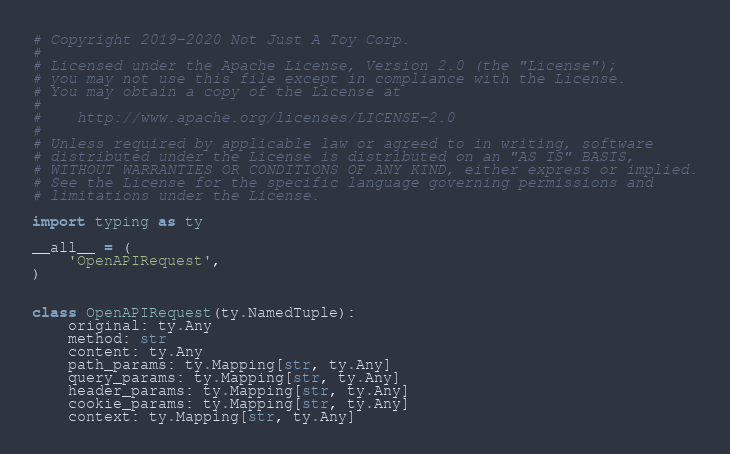<code> <loc_0><loc_0><loc_500><loc_500><_Python_># Copyright 2019-2020 Not Just A Toy Corp.
#
# Licensed under the Apache License, Version 2.0 (the "License");
# you may not use this file except in compliance with the License.
# You may obtain a copy of the License at
#
#    http://www.apache.org/licenses/LICENSE-2.0
#
# Unless required by applicable law or agreed to in writing, software
# distributed under the License is distributed on an "AS IS" BASIS,
# WITHOUT WARRANTIES OR CONDITIONS OF ANY KIND, either express or implied.
# See the License for the specific language governing permissions and
# limitations under the License.

import typing as ty

__all__ = (
    'OpenAPIRequest',
)


class OpenAPIRequest(ty.NamedTuple):
    original: ty.Any
    method: str
    content: ty.Any
    path_params: ty.Mapping[str, ty.Any]
    query_params: ty.Mapping[str, ty.Any]
    header_params: ty.Mapping[str, ty.Any]
    cookie_params: ty.Mapping[str, ty.Any]
    context: ty.Mapping[str, ty.Any]
</code> 